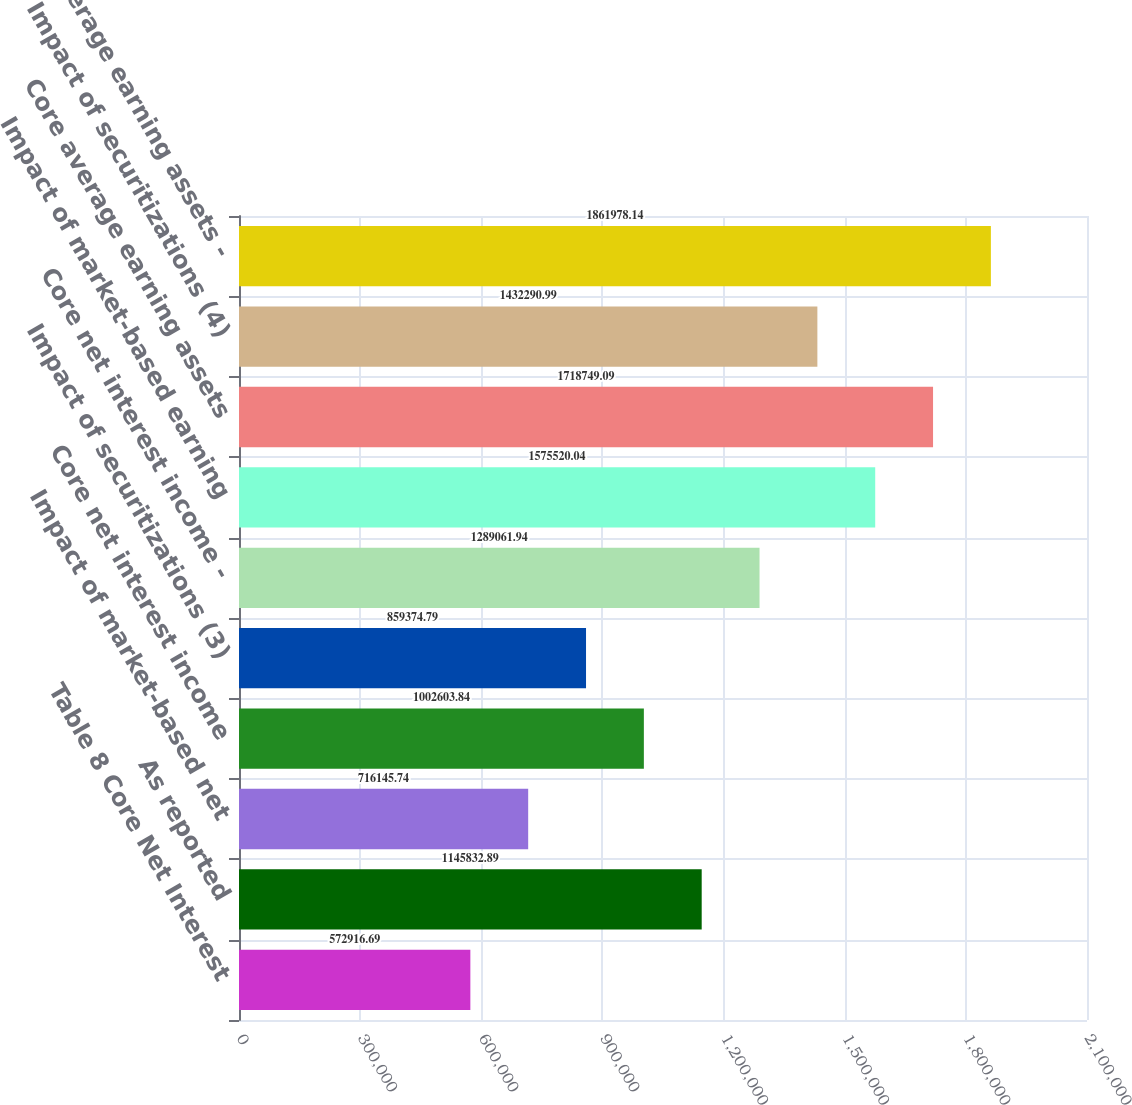Convert chart to OTSL. <chart><loc_0><loc_0><loc_500><loc_500><bar_chart><fcel>Table 8 Core Net Interest<fcel>As reported<fcel>Impact of market-based net<fcel>Core net interest income<fcel>Impact of securitizations (3)<fcel>Core net interest income -<fcel>Impact of market-based earning<fcel>Core average earning assets<fcel>Impact of securitizations (4)<fcel>Core average earning assets -<nl><fcel>572917<fcel>1.14583e+06<fcel>716146<fcel>1.0026e+06<fcel>859375<fcel>1.28906e+06<fcel>1.57552e+06<fcel>1.71875e+06<fcel>1.43229e+06<fcel>1.86198e+06<nl></chart> 